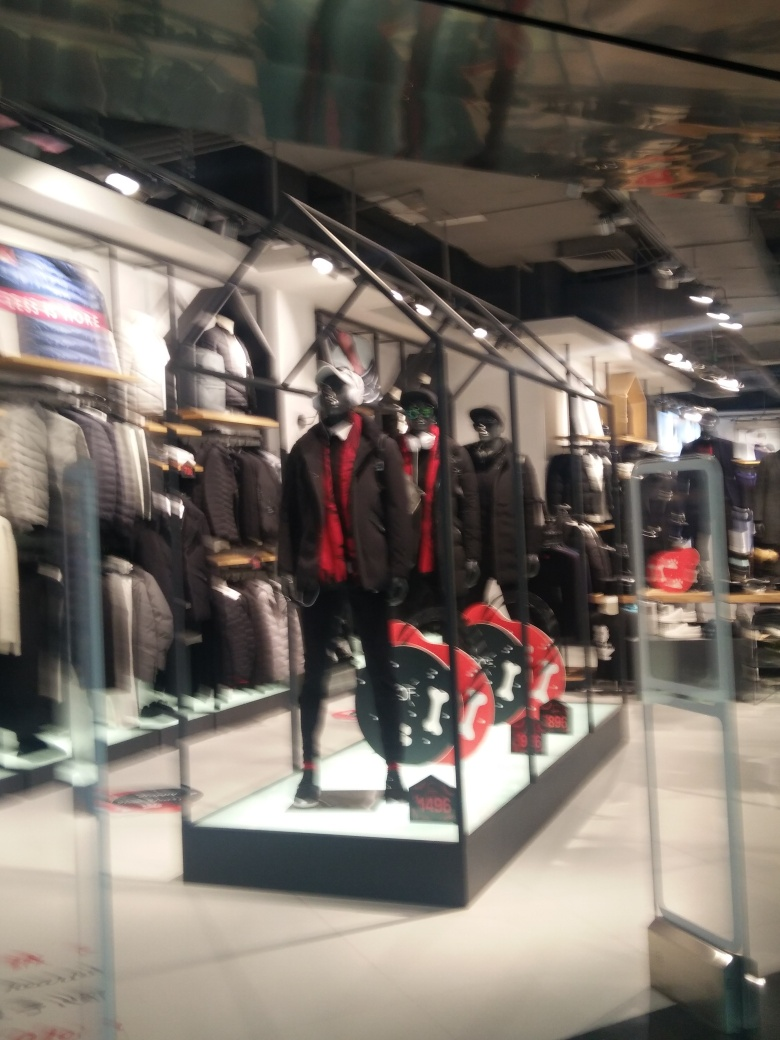How does the lighting in the store influence the display ambiance? The lighting in the store, characterized by strong overhead lights, serves to create a vibrant and appealing atmosphere. It accents the glossy finish of the mannequins and enhances the rich textures and colors of their outfits, promoting a luxurious shopping experience. 